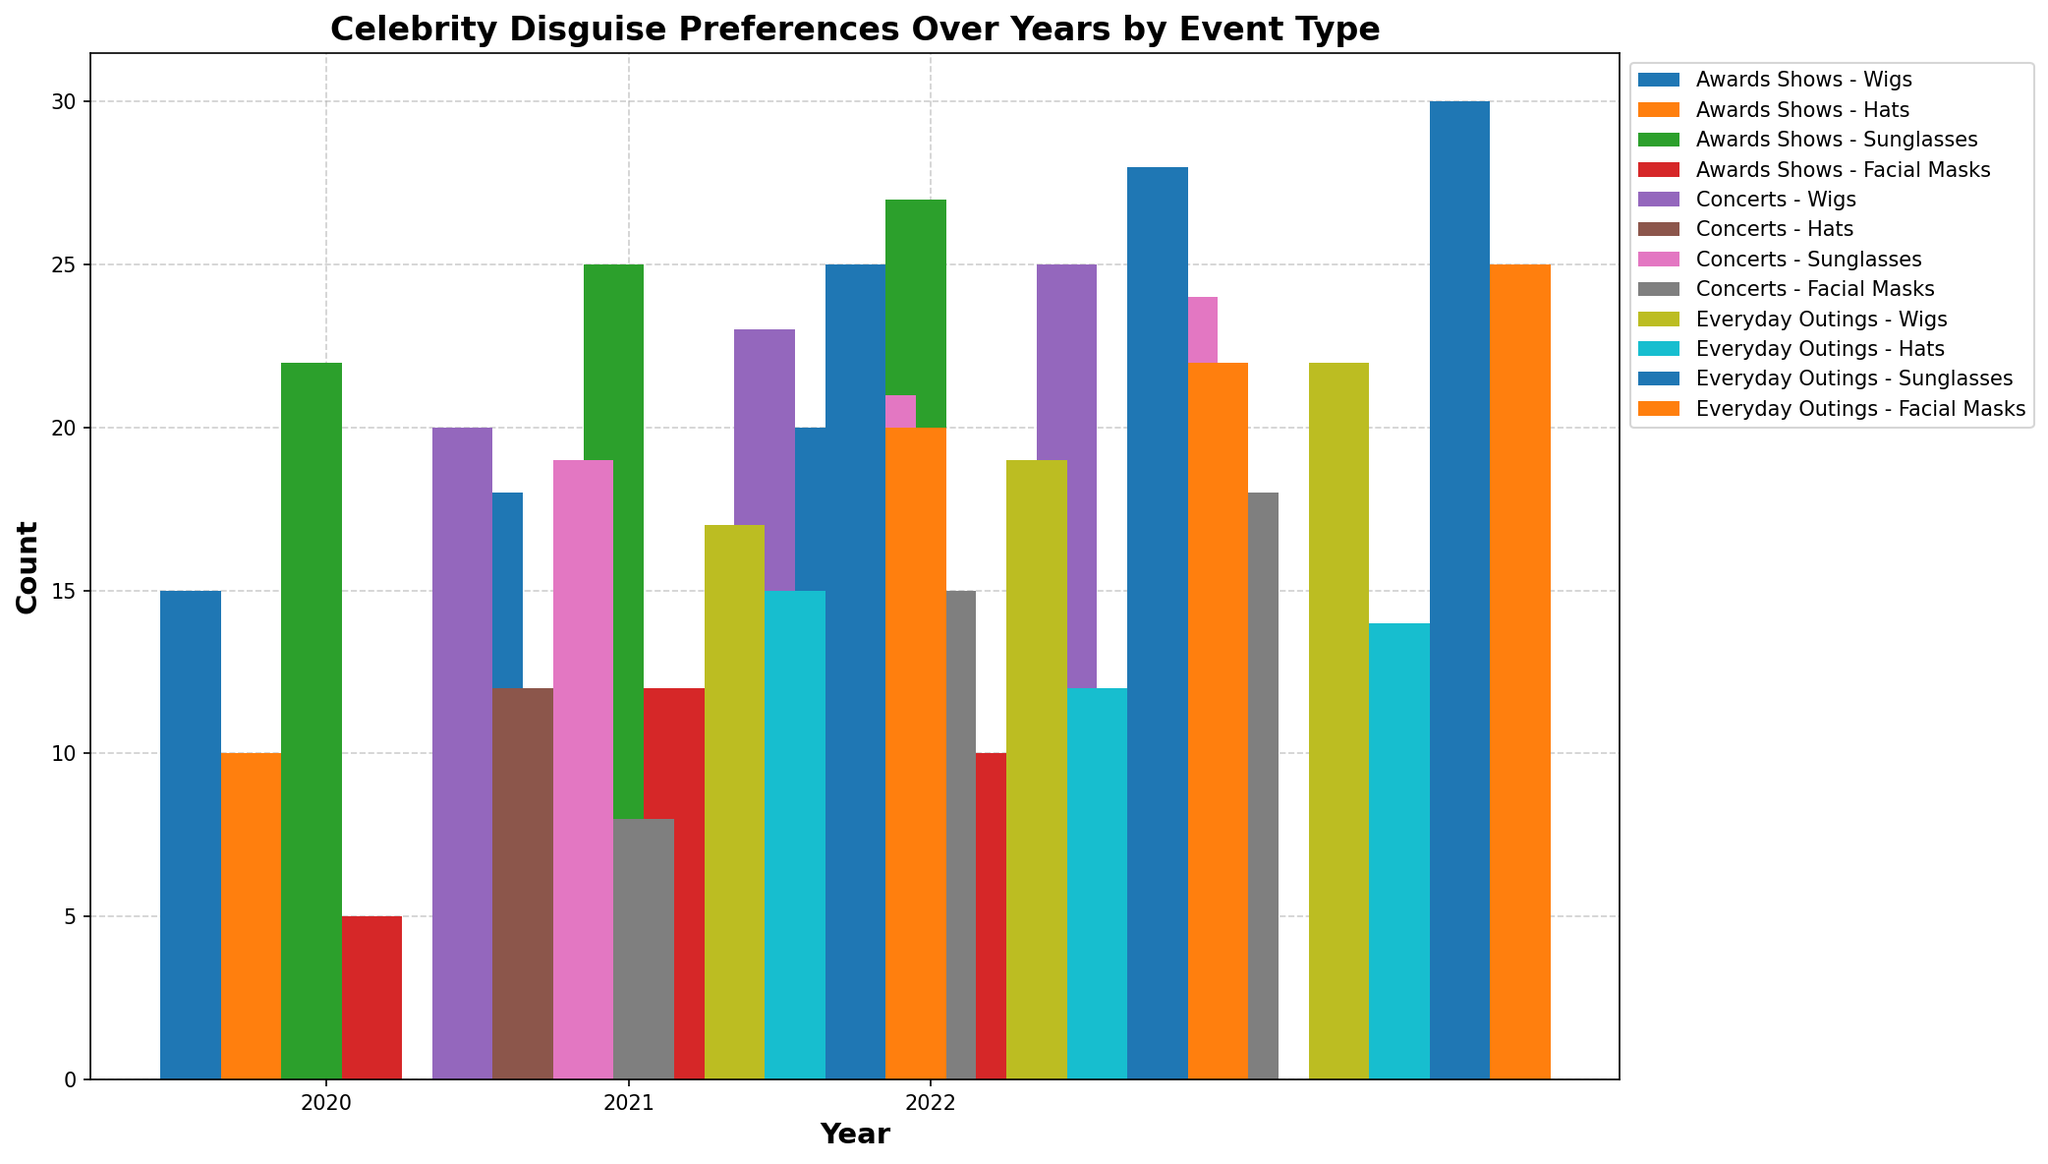What's the most preferred disguise type across all events in 2022? First, observe the tallest bars in 2022 for each event type (Awards Shows, Concerts, and Everyday Outings). The tallest bar in Awards Shows is Sunglasses (27), Concerts is Sunglasses (24), and Everyday Outings is Sunglasses (30). Hence, the most preferred disguise type across all events in 2022 is Sunglasses.
Answer: Sunglasses In which year were facial masks most used, regardless of the event type? To determine the year when facial masks were most used, examine and compare the heights of the bars representing facial masks for all years on the grouped bar plot. The tallest bar for facial masks appears in 2022 during Everyday Outings (25). Therefore, facial masks were most used in 2022.
Answer: 2022 Which event type has the highest usage of wigs in 2021? To answer this, compare the heights of the bars representing wigs for different event types in 2021. For Awards Shows, the height is 18; for Concerts, it is 23; and for Everyday Outings, it is 19. Therefore, Concerts has the highest usage of wigs in 2021.
Answer: Concerts How did the preference for hats change from 2020 to 2022 in everyday outings? Refer to the heights of the bars for hats in Everyday Outings for 2020, 2021, and 2022. In 2020, the count is 15; in 2021, it is 12; and in 2022, it is 14. The preference decreased from 2020 to 2021 and then slightly increased in 2022.
Answer: Decreased, then increased What is the total count for sunglasses usage across all years and event types? Add up the values corresponding to sunglasses across all event types and years. Awards Shows: 2020 (22) + 2021 (25) + 2022 (27), Concerts: 2020 (19) + 2021 (21) + 2022 (24), Everyday Outings: 2020 (25) + 2021 (28) + 2022 (30). This totals 22 + 25 + 27 + 19 + 21 + 24 + 25 + 28 + 30 = 221.
Answer: 221 What's the least used disguise type in awards shows over the three years? Observe the shortest bars for each disguise type in awards shows over 2020, 2021, and 2022. The disguise type with the consistently lowest counts is Facial Masks, with counts of 5 (2020), 12 (2021), and 10 (2022).
Answer: Facial Masks Is there a year where wigs were equally preferred at concerts and awards shows? Compare the bar heights for wigs at concerts and awards shows for each year. In 2020: Concerts (20) and Awards Shows (15); in 2021: Concerts (23) and Awards Shows (18); in 2022: Concerts (25) and Awards Shows (20). There is no year where the preference for wigs in concerts and awards shows is equal.
Answer: No Which year had the lowest use of any single disguise type in concerts? Review the heights of the bars for all disguise types across 2020, 2021, and 2022 in concerts. The lowest bar is for Hats in 2021, with a count of 10.
Answer: 2021 Across all three event types and years, which disguise type saw the smallest total increase or decrease in usage? Calculate the change in counts from 2020 to 2021, and 2021 to 2022, for each disguise type, then sum the absolute changes. Wigs: 15 to 18 to 20 (Awards Shows), 20 to 23 to 25 (Concerts), 17 to 19 to 22 (Everyday Outings); Hats: 10 to 8 to 9 (Awards Shows), 12 to 10 to 11 (Concerts), 15 to 12 to 14 (Everyday Outings); Sunglasses: 22 to 25 to 27 (Awards Shows), 19 to 21 to 24 (Concerts), 25 to 28 to 30 (Everyday Outings); Facial Masks: 5 to 12 to 10 (Awards Shows), 8 to 15 to 18 (Concerts), 20 to 22 to 25 (Everyday Outings). Hats saw the smallest total change: (10-8) + (8-9) + (12-10) + (10-11) + (15-12) + (12-14) = 2 + 1 + 2 + 1 + 3 + 2 = 11.
Answer: Hats 